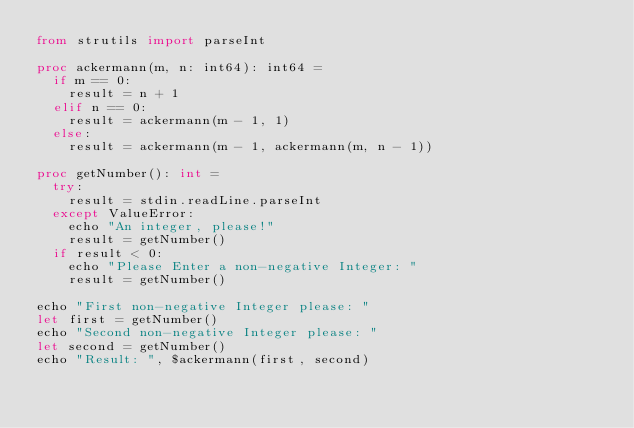<code> <loc_0><loc_0><loc_500><loc_500><_Nim_>from strutils import parseInt

proc ackermann(m, n: int64): int64 =
  if m == 0:
    result = n + 1
  elif n == 0:
    result = ackermann(m - 1, 1)
  else:
    result = ackermann(m - 1, ackermann(m, n - 1))

proc getNumber(): int =
  try:
    result = stdin.readLine.parseInt
  except ValueError:
    echo "An integer, please!"
    result = getNumber()
  if result < 0:
    echo "Please Enter a non-negative Integer: "
    result = getNumber()

echo "First non-negative Integer please: "
let first = getNumber()
echo "Second non-negative Integer please: "
let second = getNumber()
echo "Result: ", $ackermann(first, second)
</code> 